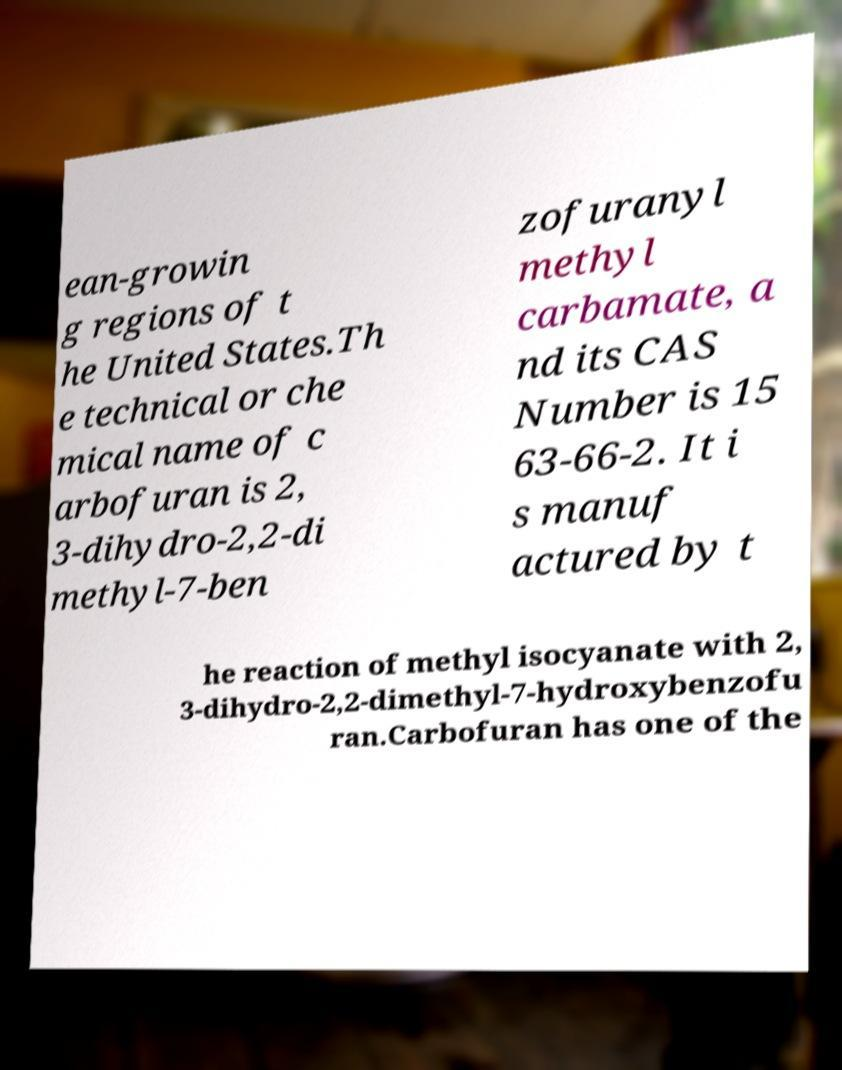Please identify and transcribe the text found in this image. ean-growin g regions of t he United States.Th e technical or che mical name of c arbofuran is 2, 3-dihydro-2,2-di methyl-7-ben zofuranyl methyl carbamate, a nd its CAS Number is 15 63-66-2. It i s manuf actured by t he reaction of methyl isocyanate with 2, 3-dihydro-2,2-dimethyl-7-hydroxybenzofu ran.Carbofuran has one of the 